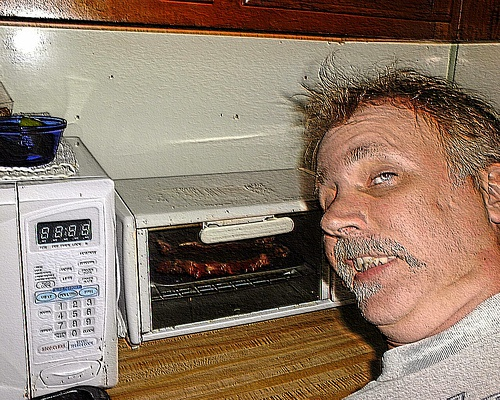Describe the objects in this image and their specific colors. I can see people in gray, tan, salmon, and black tones, oven in gray, black, darkgray, and lightgray tones, microwave in gray, lightgray, darkgray, and black tones, and bowl in gray, black, navy, blue, and darkgreen tones in this image. 